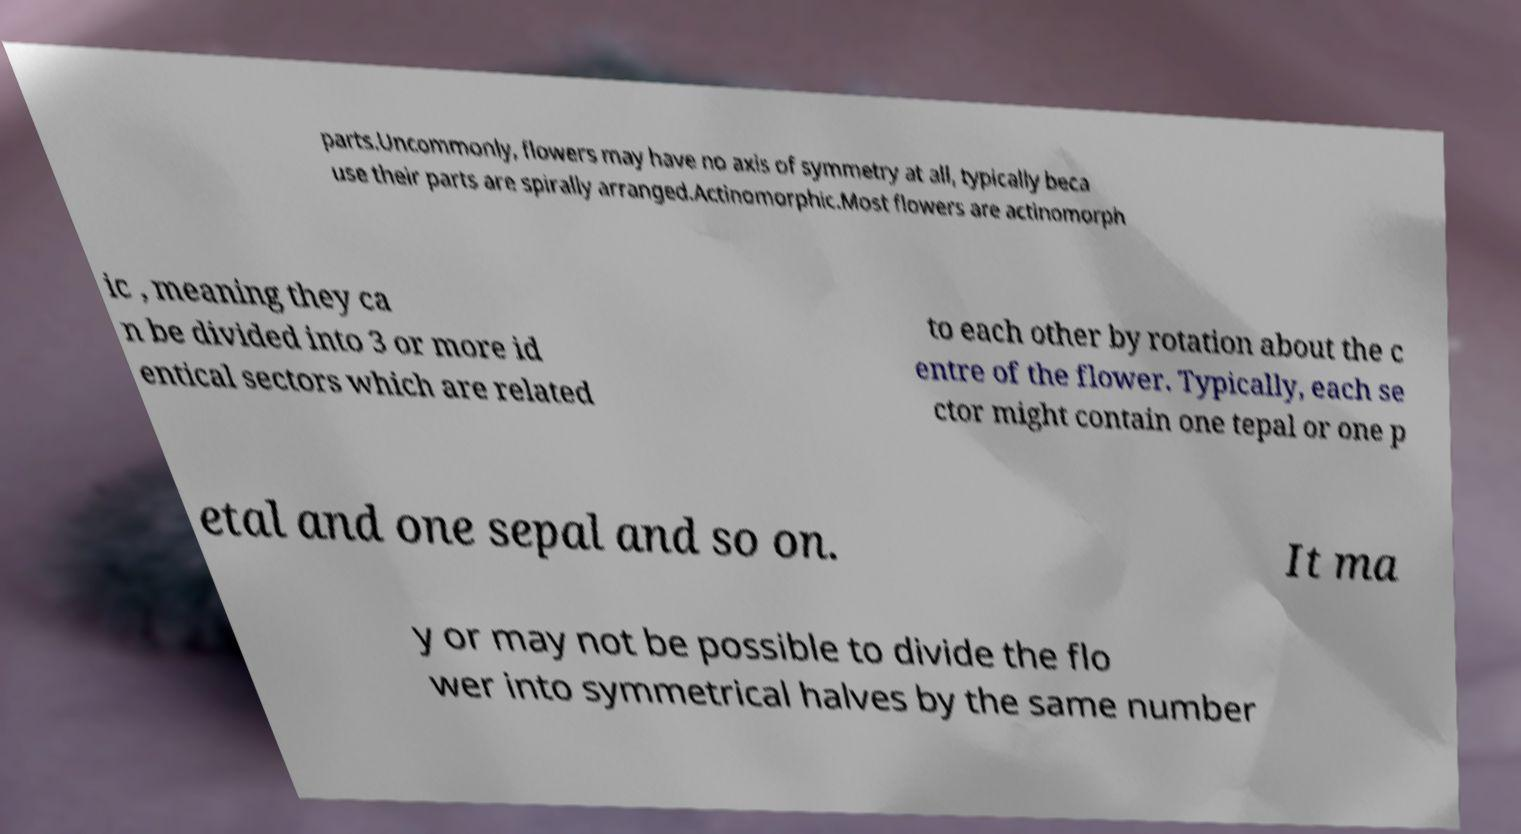Please identify and transcribe the text found in this image. parts.Uncommonly, flowers may have no axis of symmetry at all, typically beca use their parts are spirally arranged.Actinomorphic.Most flowers are actinomorph ic , meaning they ca n be divided into 3 or more id entical sectors which are related to each other by rotation about the c entre of the flower. Typically, each se ctor might contain one tepal or one p etal and one sepal and so on. It ma y or may not be possible to divide the flo wer into symmetrical halves by the same number 